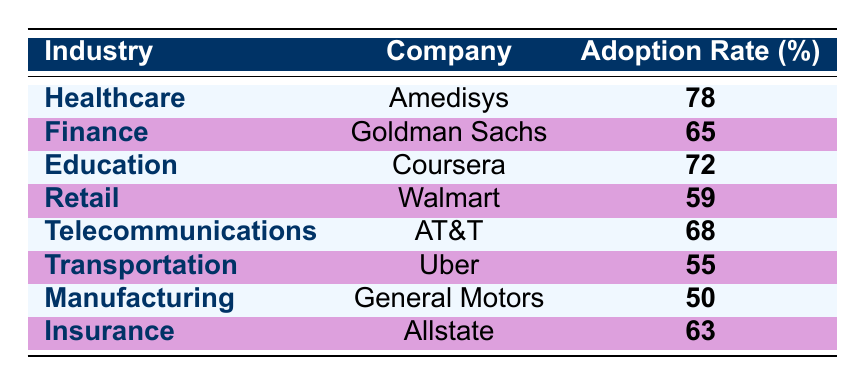What is the adoption rate for the healthcare industry? The table shows that the healthcare industry has an adoption rate of 78%, as indicated in the row for Amedisys under the healthcare category.
Answer: 78% Which company has the highest user adoption rate? Amedisys in the healthcare industry has the highest adoption rate of 78%, which is more than any other company's rates listed in the table.
Answer: Amedisys What is the difference between the adoption rate of education and manufacturing? The adoption rate for education is 72% (Coursera) and for manufacturing is 50% (General Motors). The difference is calculated as 72 - 50 = 22%.
Answer: 22% Is the adoption rate for telecommunications higher than that for transportation? The telecommunication adoption rate is 68% (AT&T) while transportation is 55% (Uber). Since 68% is greater than 55%, the statement is true.
Answer: Yes What is the average adoption rate across all listed industries? To find the average, sum the adoption rates: 78 + 65 + 72 + 59 + 68 + 55 + 50 + 63 =  478. There are 8 industries, so the average is 478 / 8 = 59.75%.
Answer: 59.75% Which industry has the lowest adoption rate and what is that rate? From reviewing the adoption rates listed in the table, the manufacturing industry (General Motors) has the lowest rate at 50%.
Answer: Manufacturing, 50% Is the adoption rate for insurance higher than that for retail? The adoption rate for insurance (63% with Allstate) is compared to retail (59% with Walmart). Since 63% is greater than 59%, the answer is yes.
Answer: Yes What company represents the finance industry and what is its adoption rate? Goldman Sachs represents the finance industry, and it has a user adoption rate of 65%, as shown in the specific row for finance.
Answer: Goldman Sachs, 65% How many companies have an adoption rate of 60% or higher? Analyzing the rates, the companies with 60% or higher are Amedisys (78%), Goldman Sachs (65%), Coursera (72%), AT&T (68%), and Allstate (63%). This totals to 5 companies.
Answer: 5 